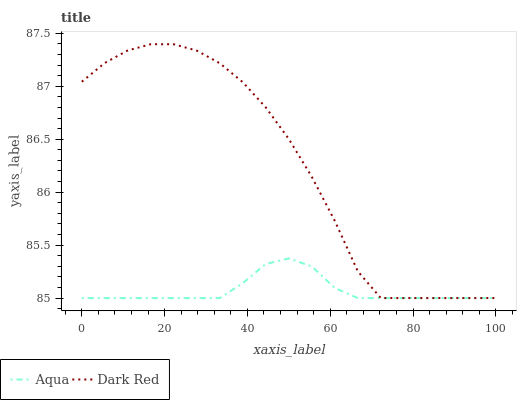Does Aqua have the maximum area under the curve?
Answer yes or no. No. Is Aqua the roughest?
Answer yes or no. No. Does Aqua have the highest value?
Answer yes or no. No. 